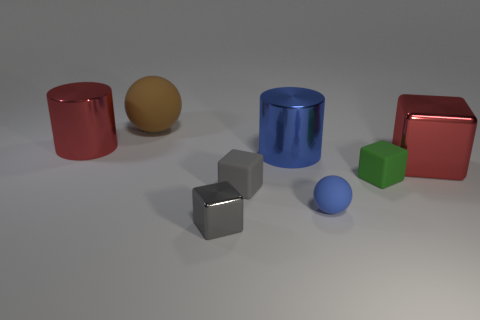Can you describe the shapes and colors present in the image? Certainly! The image features a collection of geometric solids. There are two cylinders, one red and one cyan; two cubes, one silver and one green; two spheres, a small blue one and a larger yellow one; and a red cuboid. All objects have a shiny surface, giving the impression of being made from materials like plastic or polished metal. 